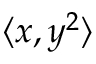Convert formula to latex. <formula><loc_0><loc_0><loc_500><loc_500>\langle x , y ^ { 2 } \rangle</formula> 